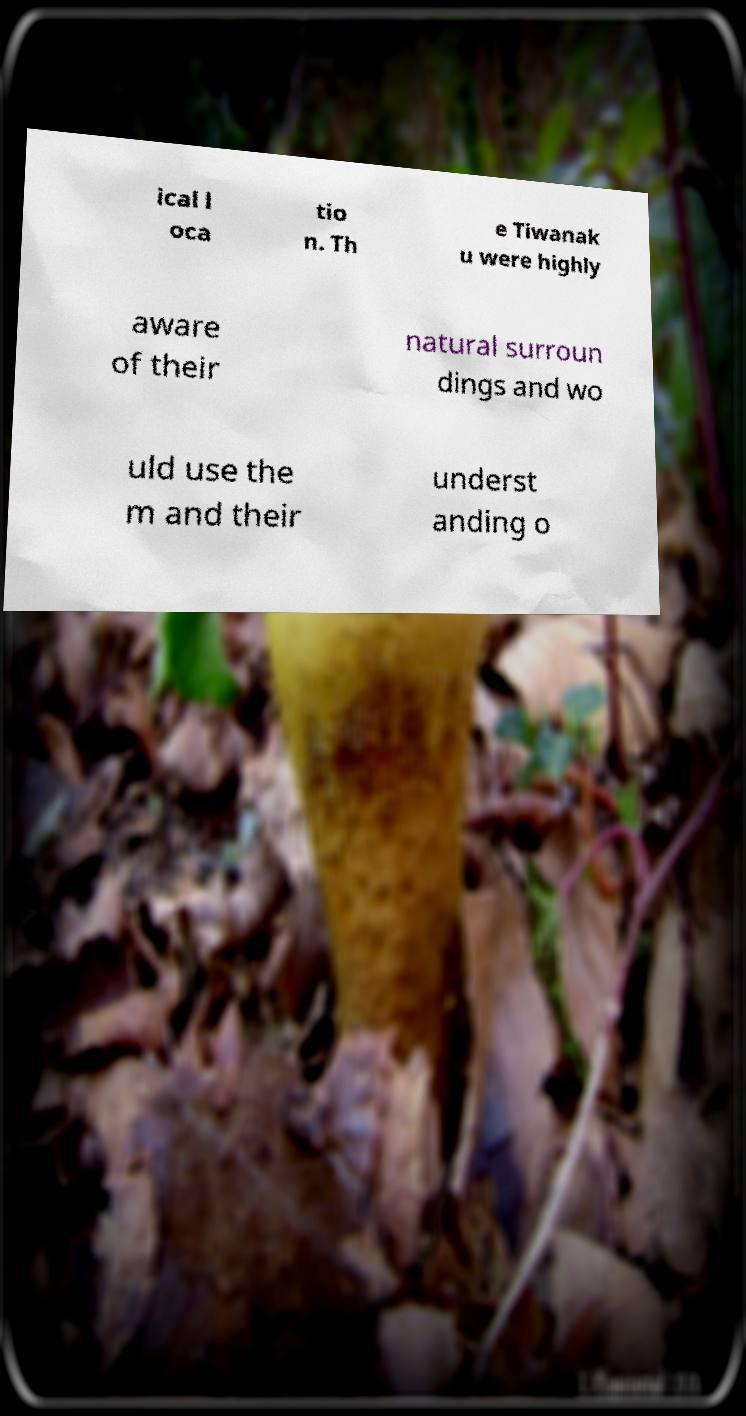I need the written content from this picture converted into text. Can you do that? ical l oca tio n. Th e Tiwanak u were highly aware of their natural surroun dings and wo uld use the m and their underst anding o 